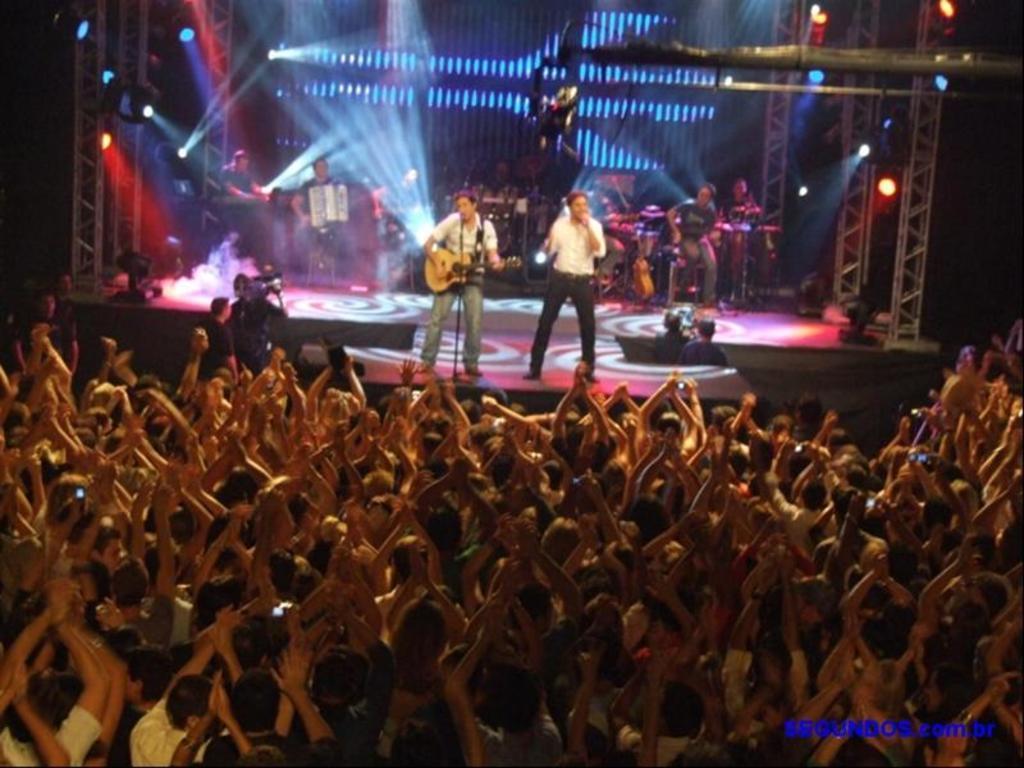How would you summarize this image in a sentence or two? In this image we can see a few people, among them some people are playing the musical instruments on the stage, also we can see some focus lights and pillars, in the background it looks like the wall. 